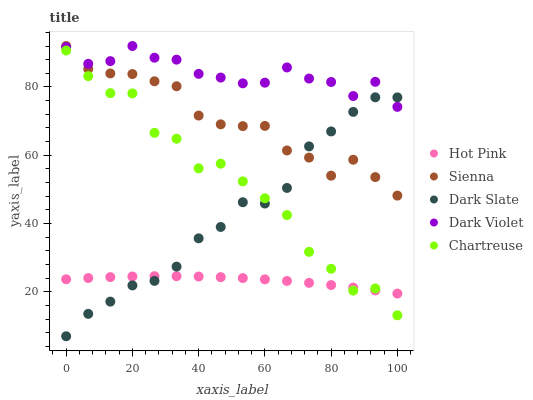Does Hot Pink have the minimum area under the curve?
Answer yes or no. Yes. Does Dark Violet have the maximum area under the curve?
Answer yes or no. Yes. Does Dark Slate have the minimum area under the curve?
Answer yes or no. No. Does Dark Slate have the maximum area under the curve?
Answer yes or no. No. Is Hot Pink the smoothest?
Answer yes or no. Yes. Is Chartreuse the roughest?
Answer yes or no. Yes. Is Dark Slate the smoothest?
Answer yes or no. No. Is Dark Slate the roughest?
Answer yes or no. No. Does Dark Slate have the lowest value?
Answer yes or no. Yes. Does Chartreuse have the lowest value?
Answer yes or no. No. Does Dark Violet have the highest value?
Answer yes or no. Yes. Does Dark Slate have the highest value?
Answer yes or no. No. Is Hot Pink less than Dark Violet?
Answer yes or no. Yes. Is Dark Violet greater than Chartreuse?
Answer yes or no. Yes. Does Sienna intersect Dark Slate?
Answer yes or no. Yes. Is Sienna less than Dark Slate?
Answer yes or no. No. Is Sienna greater than Dark Slate?
Answer yes or no. No. Does Hot Pink intersect Dark Violet?
Answer yes or no. No. 